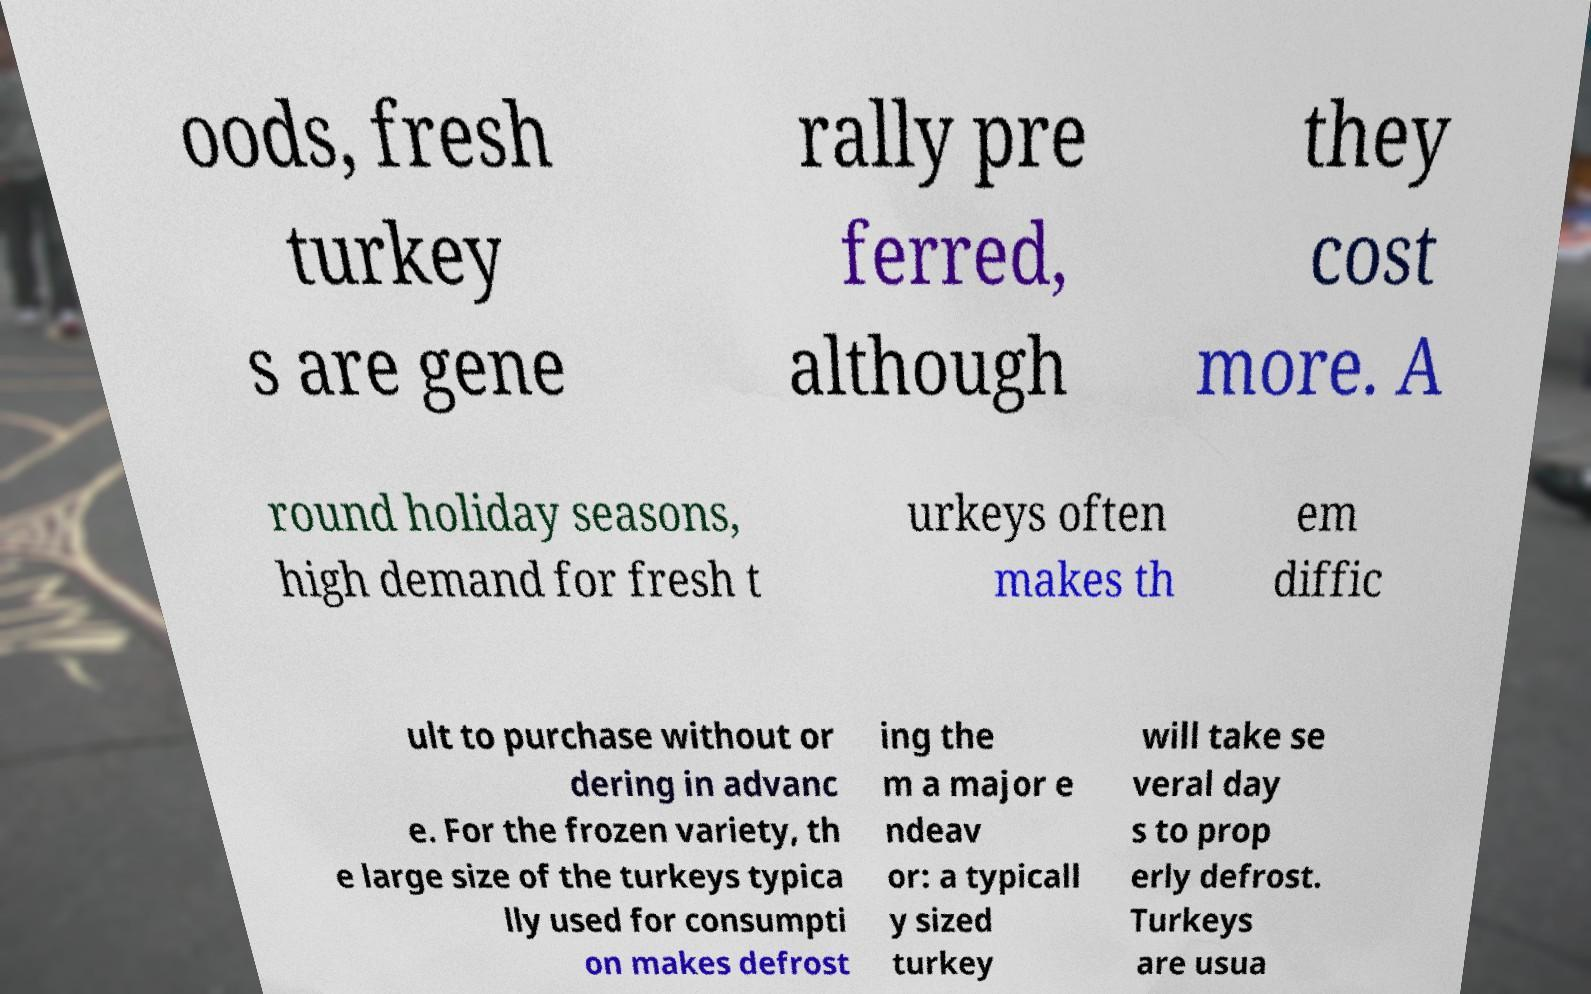I need the written content from this picture converted into text. Can you do that? oods, fresh turkey s are gene rally pre ferred, although they cost more. A round holiday seasons, high demand for fresh t urkeys often makes th em diffic ult to purchase without or dering in advanc e. For the frozen variety, th e large size of the turkeys typica lly used for consumpti on makes defrost ing the m a major e ndeav or: a typicall y sized turkey will take se veral day s to prop erly defrost. Turkeys are usua 